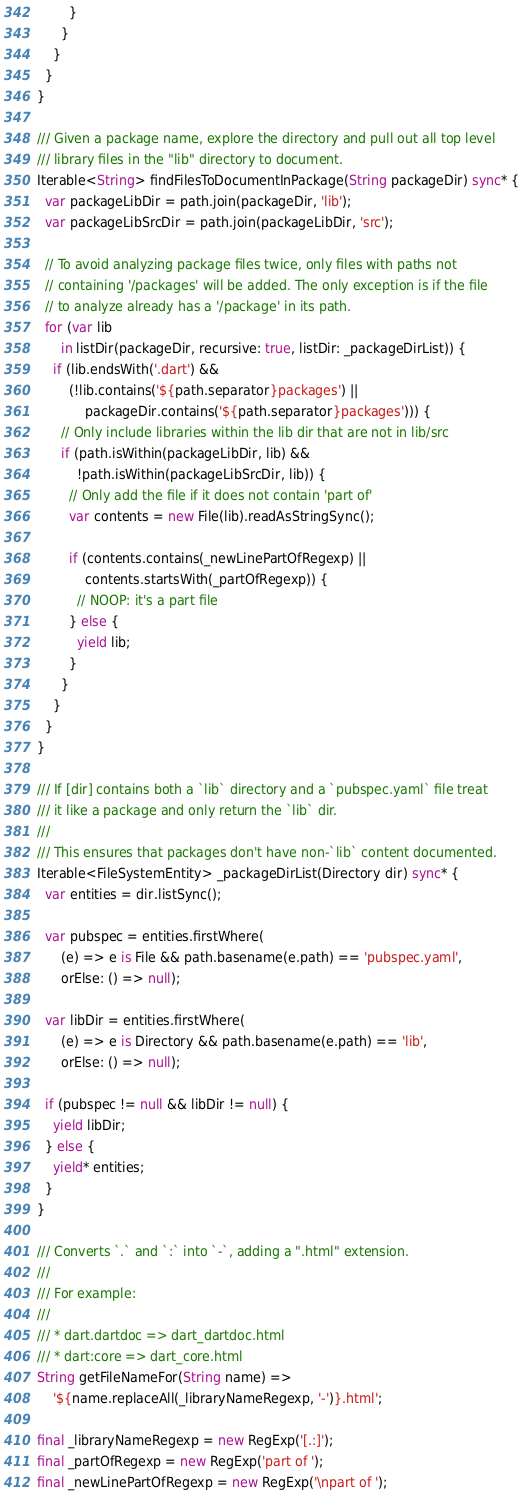Convert code to text. <code><loc_0><loc_0><loc_500><loc_500><_Dart_>        }
      }
    }
  }
}

/// Given a package name, explore the directory and pull out all top level
/// library files in the "lib" directory to document.
Iterable<String> findFilesToDocumentInPackage(String packageDir) sync* {
  var packageLibDir = path.join(packageDir, 'lib');
  var packageLibSrcDir = path.join(packageLibDir, 'src');

  // To avoid analyzing package files twice, only files with paths not
  // containing '/packages' will be added. The only exception is if the file
  // to analyze already has a '/package' in its path.
  for (var lib
      in listDir(packageDir, recursive: true, listDir: _packageDirList)) {
    if (lib.endsWith('.dart') &&
        (!lib.contains('${path.separator}packages') ||
            packageDir.contains('${path.separator}packages'))) {
      // Only include libraries within the lib dir that are not in lib/src
      if (path.isWithin(packageLibDir, lib) &&
          !path.isWithin(packageLibSrcDir, lib)) {
        // Only add the file if it does not contain 'part of'
        var contents = new File(lib).readAsStringSync();

        if (contents.contains(_newLinePartOfRegexp) ||
            contents.startsWith(_partOfRegexp)) {
          // NOOP: it's a part file
        } else {
          yield lib;
        }
      }
    }
  }
}

/// If [dir] contains both a `lib` directory and a `pubspec.yaml` file treat
/// it like a package and only return the `lib` dir.
///
/// This ensures that packages don't have non-`lib` content documented.
Iterable<FileSystemEntity> _packageDirList(Directory dir) sync* {
  var entities = dir.listSync();

  var pubspec = entities.firstWhere(
      (e) => e is File && path.basename(e.path) == 'pubspec.yaml',
      orElse: () => null);

  var libDir = entities.firstWhere(
      (e) => e is Directory && path.basename(e.path) == 'lib',
      orElse: () => null);

  if (pubspec != null && libDir != null) {
    yield libDir;
  } else {
    yield* entities;
  }
}

/// Converts `.` and `:` into `-`, adding a ".html" extension.
///
/// For example:
///
/// * dart.dartdoc => dart_dartdoc.html
/// * dart:core => dart_core.html
String getFileNameFor(String name) =>
    '${name.replaceAll(_libraryNameRegexp, '-')}.html';

final _libraryNameRegexp = new RegExp('[.:]');
final _partOfRegexp = new RegExp('part of ');
final _newLinePartOfRegexp = new RegExp('\npart of ');
</code> 